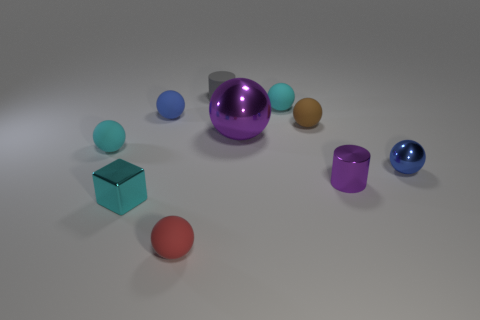Subtract all purple cylinders. How many cyan balls are left? 2 Subtract all brown spheres. How many spheres are left? 6 Subtract 4 spheres. How many spheres are left? 3 Subtract all brown balls. How many balls are left? 6 Subtract all gray balls. Subtract all cyan cylinders. How many balls are left? 7 Subtract all cylinders. How many objects are left? 8 Subtract 2 blue spheres. How many objects are left? 8 Subtract all cyan metal objects. Subtract all large blue blocks. How many objects are left? 9 Add 1 small blocks. How many small blocks are left? 2 Add 8 gray matte cylinders. How many gray matte cylinders exist? 9 